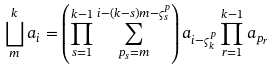<formula> <loc_0><loc_0><loc_500><loc_500>\bigsqcup _ { m } ^ { k } a _ { i } = \left ( \prod _ { s = 1 } ^ { k - 1 } \sum _ { p _ { s } = m } ^ { i - ( k - s ) m - \varsigma _ { s } ^ { p } } \right ) a _ { i - \varsigma _ { k } ^ { p } } \prod _ { r = 1 } ^ { k - 1 } a _ { p _ { r } }</formula> 